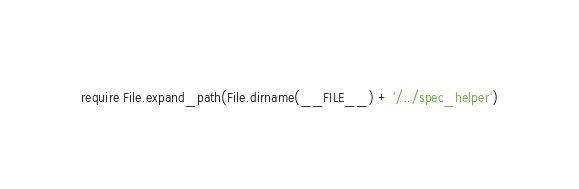Convert code to text. <code><loc_0><loc_0><loc_500><loc_500><_Ruby_>require File.expand_path(File.dirname(__FILE__) + '/../spec_helper')</code> 